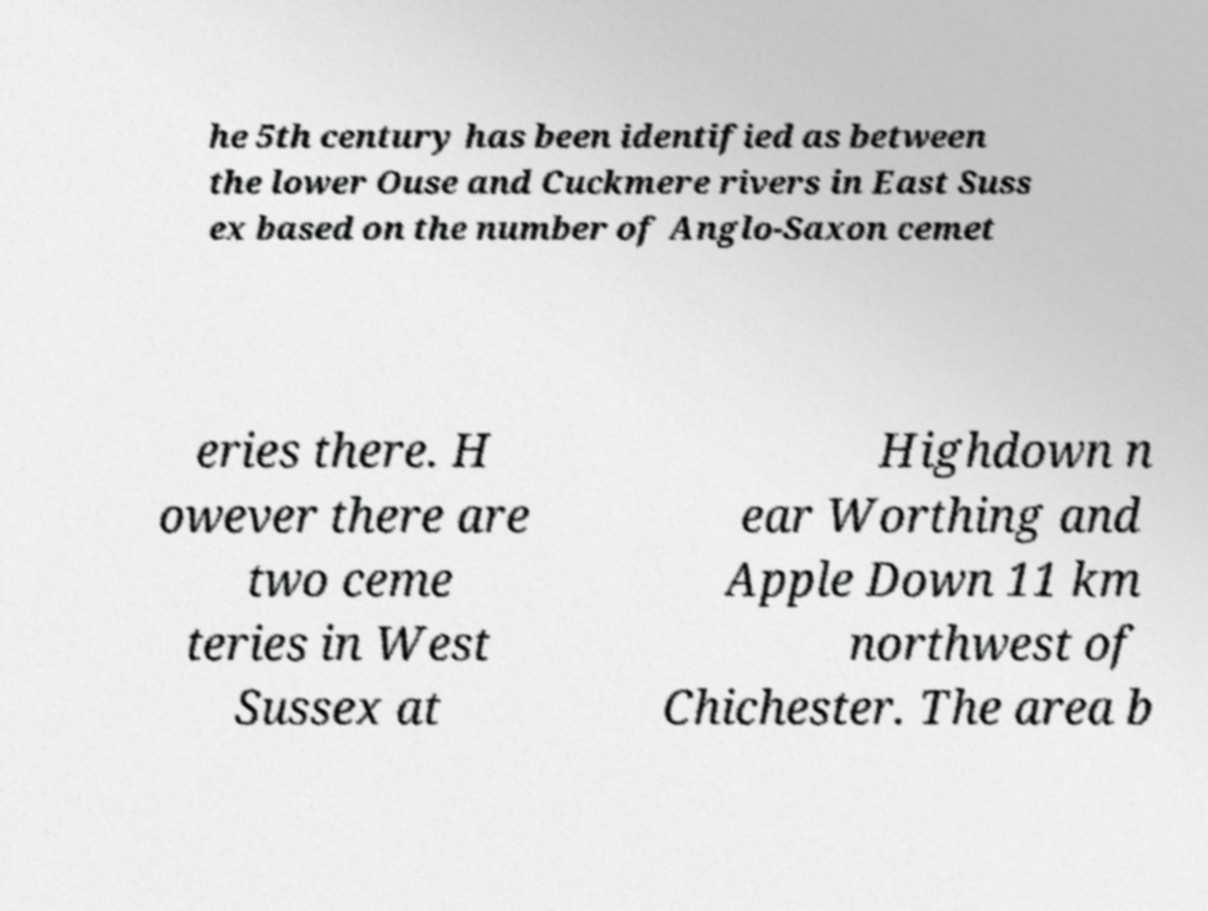What messages or text are displayed in this image? I need them in a readable, typed format. he 5th century has been identified as between the lower Ouse and Cuckmere rivers in East Suss ex based on the number of Anglo-Saxon cemet eries there. H owever there are two ceme teries in West Sussex at Highdown n ear Worthing and Apple Down 11 km northwest of Chichester. The area b 